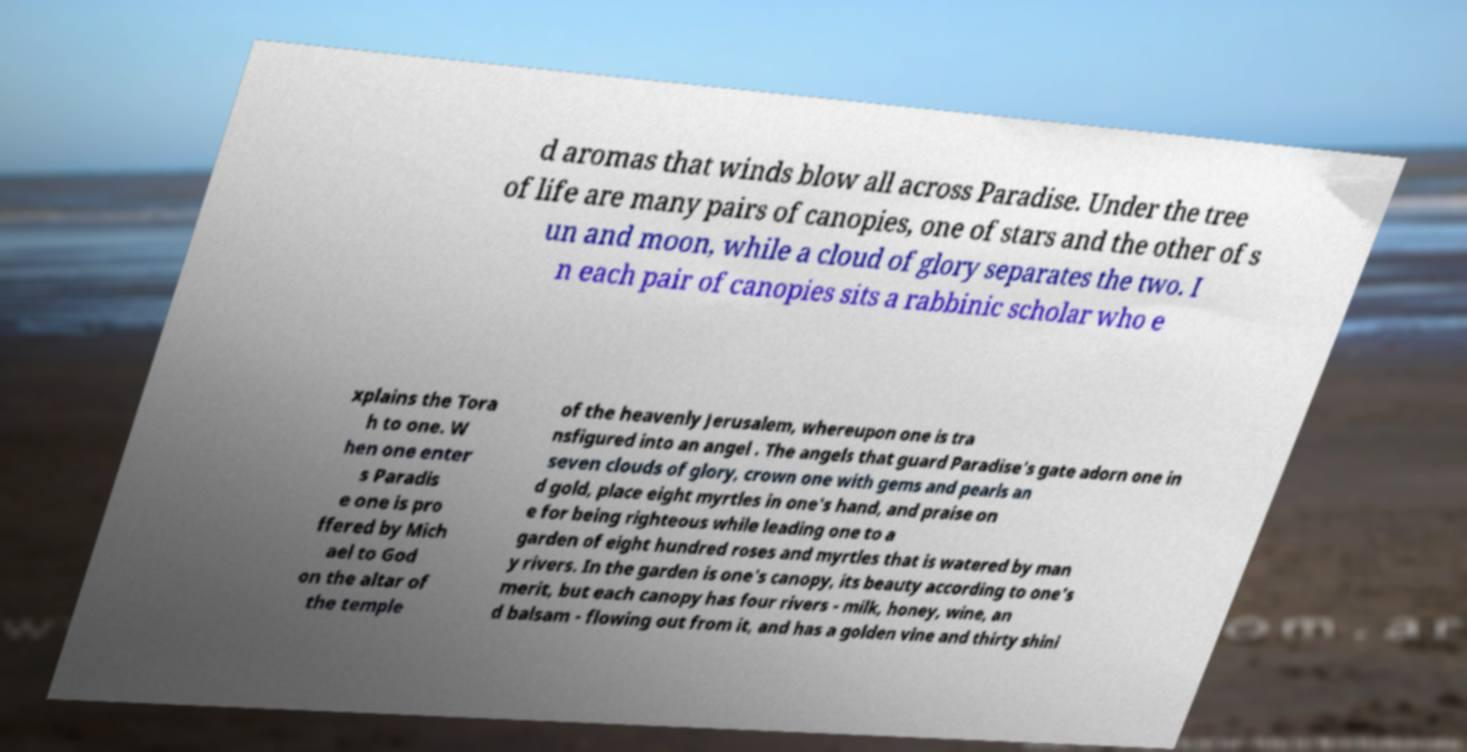I need the written content from this picture converted into text. Can you do that? d aromas that winds blow all across Paradise. Under the tree of life are many pairs of canopies, one of stars and the other of s un and moon, while a cloud of glory separates the two. I n each pair of canopies sits a rabbinic scholar who e xplains the Tora h to one. W hen one enter s Paradis e one is pro ffered by Mich ael to God on the altar of the temple of the heavenly Jerusalem, whereupon one is tra nsfigured into an angel . The angels that guard Paradise's gate adorn one in seven clouds of glory, crown one with gems and pearls an d gold, place eight myrtles in one's hand, and praise on e for being righteous while leading one to a garden of eight hundred roses and myrtles that is watered by man y rivers. In the garden is one's canopy, its beauty according to one's merit, but each canopy has four rivers - milk, honey, wine, an d balsam - flowing out from it, and has a golden vine and thirty shini 